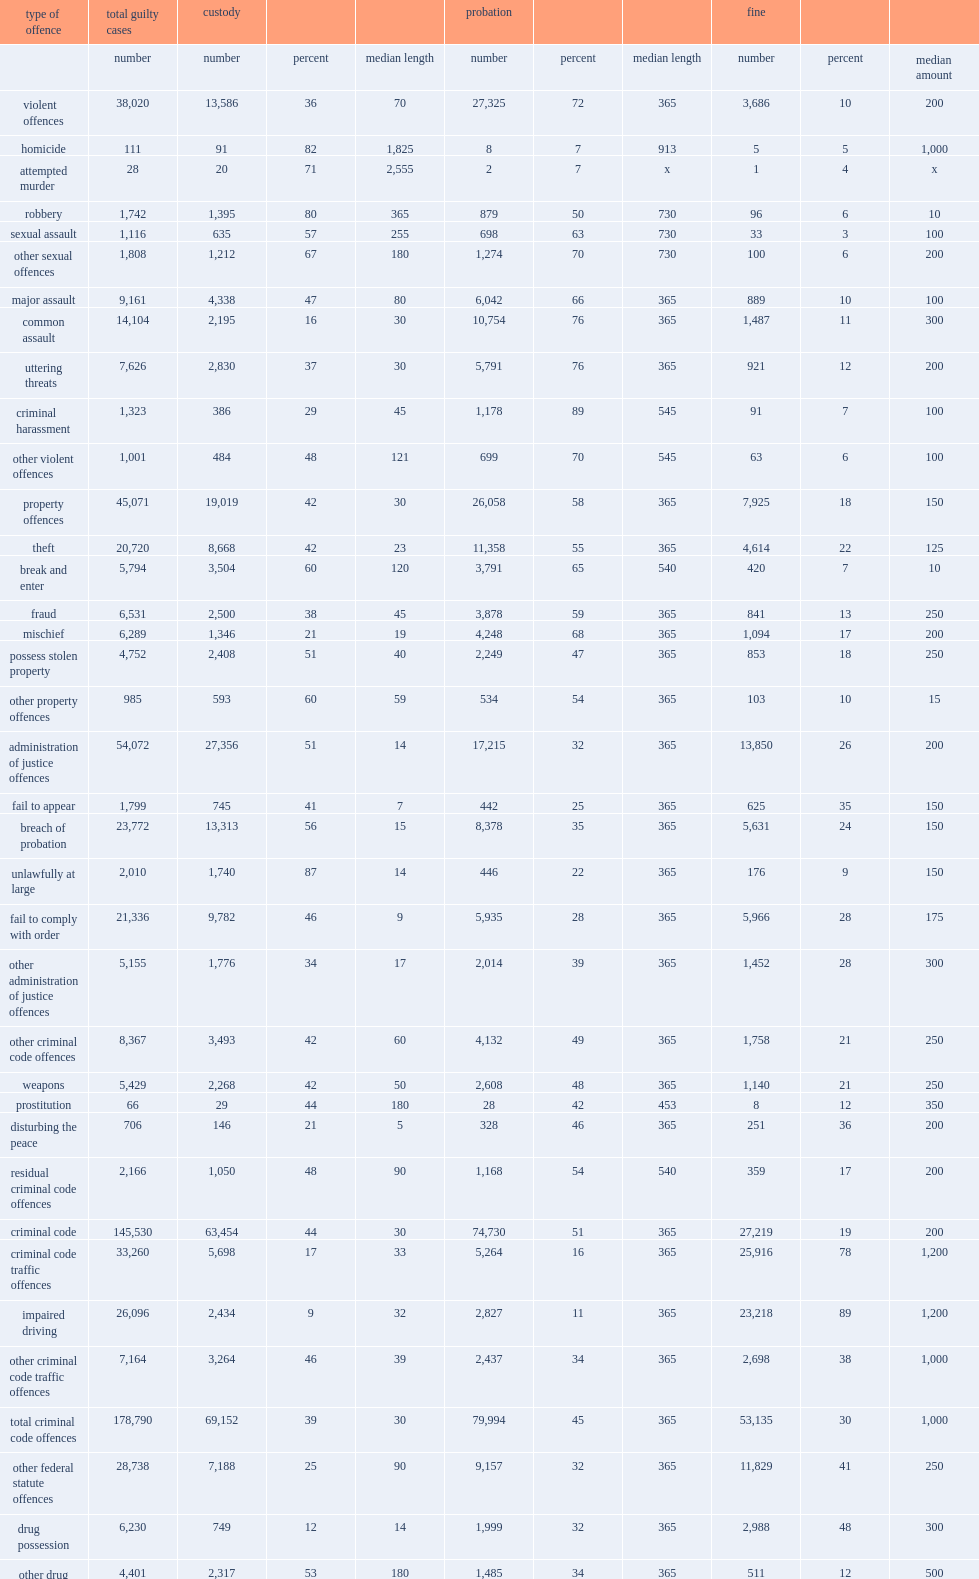In 2014/2015, how many percentage points have probation sentences been imposed for cases involving criminal harassment? 89.0. In 2014/2015, how many percentage points have probation sentences been imposed for cases involving uttering threats? 76.0. In 2014/2015, how many percentage points have probation sentences been imposed for cases involving common assault? 76.0. How many percentage points did cases involving impaired driving receive probation sentences? 11.0. In 2014/2015, what is the the median length of probation in canada? 365.0. How many percentage points have probation been imposed in all homicide cases completed in adult criminal court in 2014/2015? 7.0. How many percentage points have a fine been imposed in adult criminal court in 2014/2015? 31.0. How many dollars was the the median amount of fine imposed in 2014/2015? 500.0. What percentage did impaired driving cases receive a fine sentence in 2014/2015? 0.889715. How many percentage points have custodial sentences been imposed in guilty adult criminal court cases in 2014/2015? 37.0. What was the median length of a custodial sentence in 2014/2015? 30.0. How many percentage points did canada as a whole impose custodial sentences in all impaired driving cases? 9.0. 